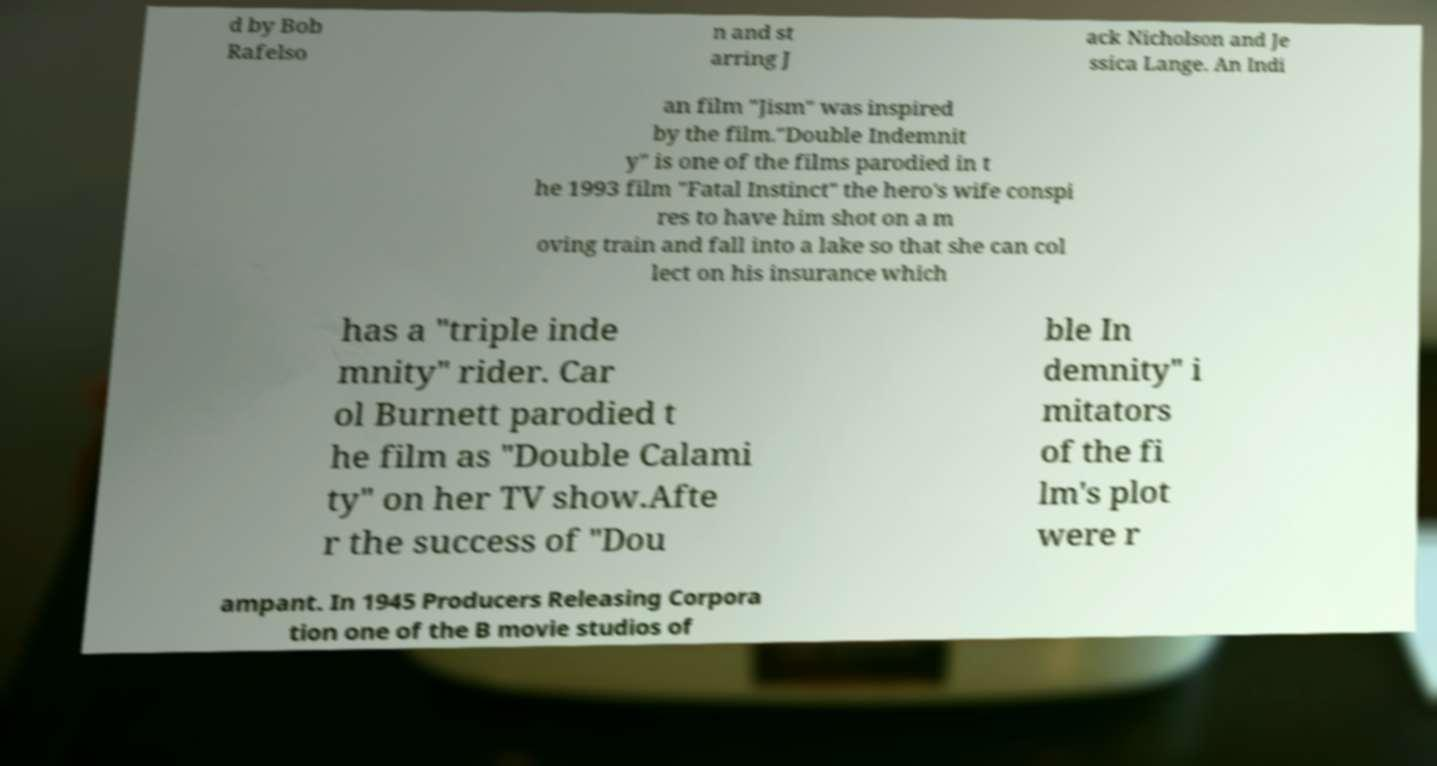Could you extract and type out the text from this image? d by Bob Rafelso n and st arring J ack Nicholson and Je ssica Lange. An Indi an film "Jism" was inspired by the film."Double Indemnit y" is one of the films parodied in t he 1993 film "Fatal Instinct" the hero's wife conspi res to have him shot on a m oving train and fall into a lake so that she can col lect on his insurance which has a "triple inde mnity" rider. Car ol Burnett parodied t he film as "Double Calami ty" on her TV show.Afte r the success of "Dou ble In demnity" i mitators of the fi lm's plot were r ampant. In 1945 Producers Releasing Corpora tion one of the B movie studios of 